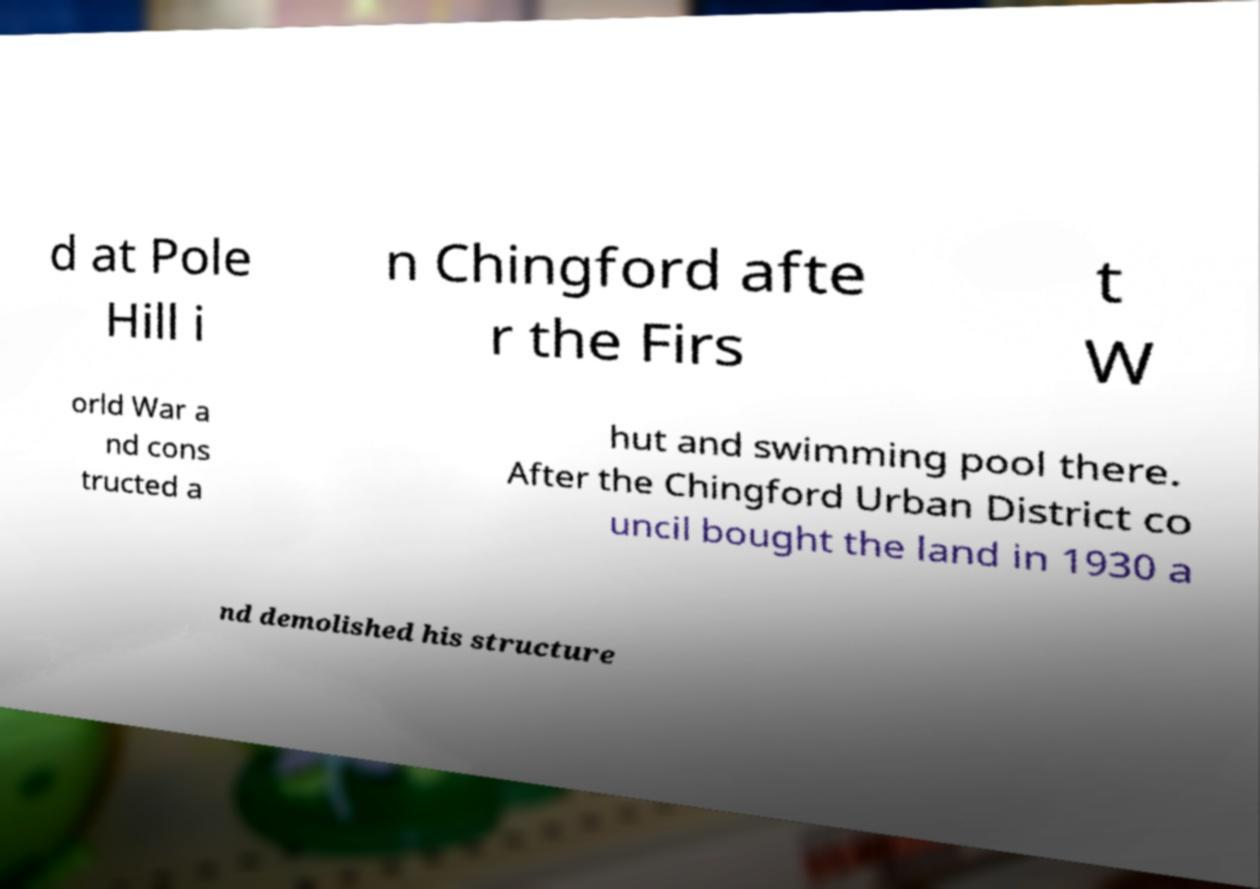Please identify and transcribe the text found in this image. d at Pole Hill i n Chingford afte r the Firs t W orld War a nd cons tructed a hut and swimming pool there. After the Chingford Urban District co uncil bought the land in 1930 a nd demolished his structure 